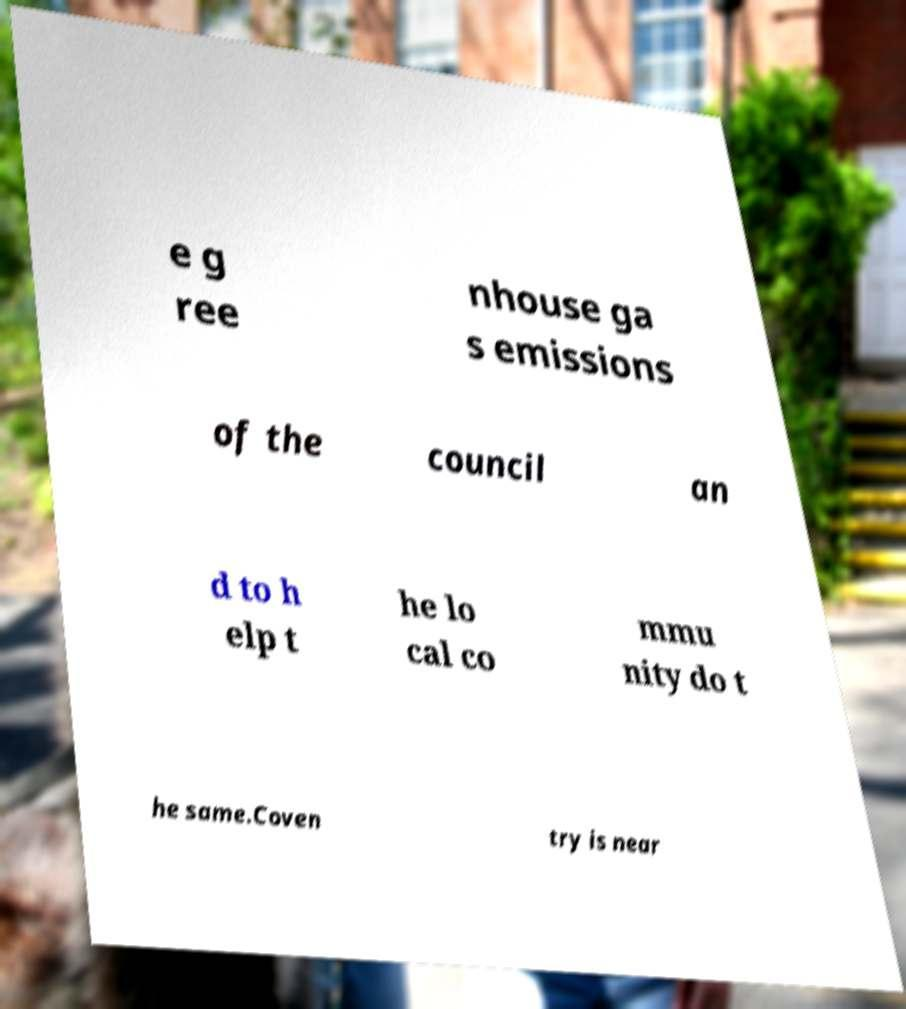I need the written content from this picture converted into text. Can you do that? e g ree nhouse ga s emissions of the council an d to h elp t he lo cal co mmu nity do t he same.Coven try is near 